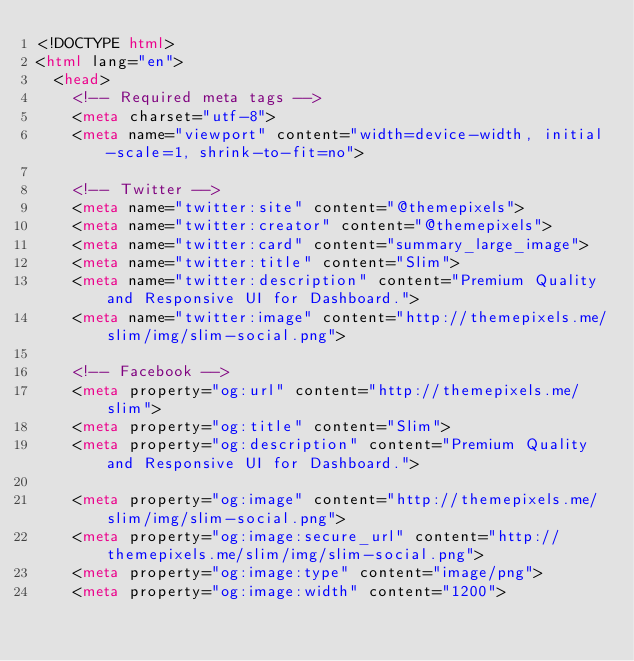Convert code to text. <code><loc_0><loc_0><loc_500><loc_500><_HTML_><!DOCTYPE html>
<html lang="en">
  <head>
    <!-- Required meta tags -->
    <meta charset="utf-8">
    <meta name="viewport" content="width=device-width, initial-scale=1, shrink-to-fit=no">

    <!-- Twitter -->
    <meta name="twitter:site" content="@themepixels">
    <meta name="twitter:creator" content="@themepixels">
    <meta name="twitter:card" content="summary_large_image">
    <meta name="twitter:title" content="Slim">
    <meta name="twitter:description" content="Premium Quality and Responsive UI for Dashboard.">
    <meta name="twitter:image" content="http://themepixels.me/slim/img/slim-social.png">

    <!-- Facebook -->
    <meta property="og:url" content="http://themepixels.me/slim">
    <meta property="og:title" content="Slim">
    <meta property="og:description" content="Premium Quality and Responsive UI for Dashboard.">

    <meta property="og:image" content="http://themepixels.me/slim/img/slim-social.png">
    <meta property="og:image:secure_url" content="http://themepixels.me/slim/img/slim-social.png">
    <meta property="og:image:type" content="image/png">
    <meta property="og:image:width" content="1200"></code> 